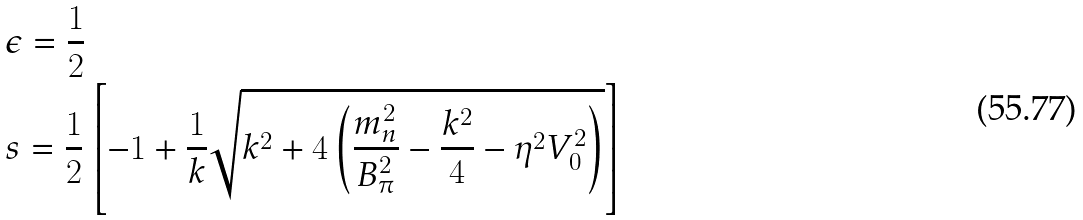Convert formula to latex. <formula><loc_0><loc_0><loc_500><loc_500>& \epsilon = \frac { 1 } { 2 } \\ & s = \frac { 1 } { 2 } \left [ - 1 + \frac { 1 } { k } \sqrt { k ^ { 2 } + 4 \left ( \frac { m _ { n } ^ { 2 } } { B _ { \pi } ^ { 2 } } - \frac { k ^ { 2 } } { 4 } - \eta ^ { 2 } V _ { 0 } ^ { 2 } \right ) } \right ]</formula> 